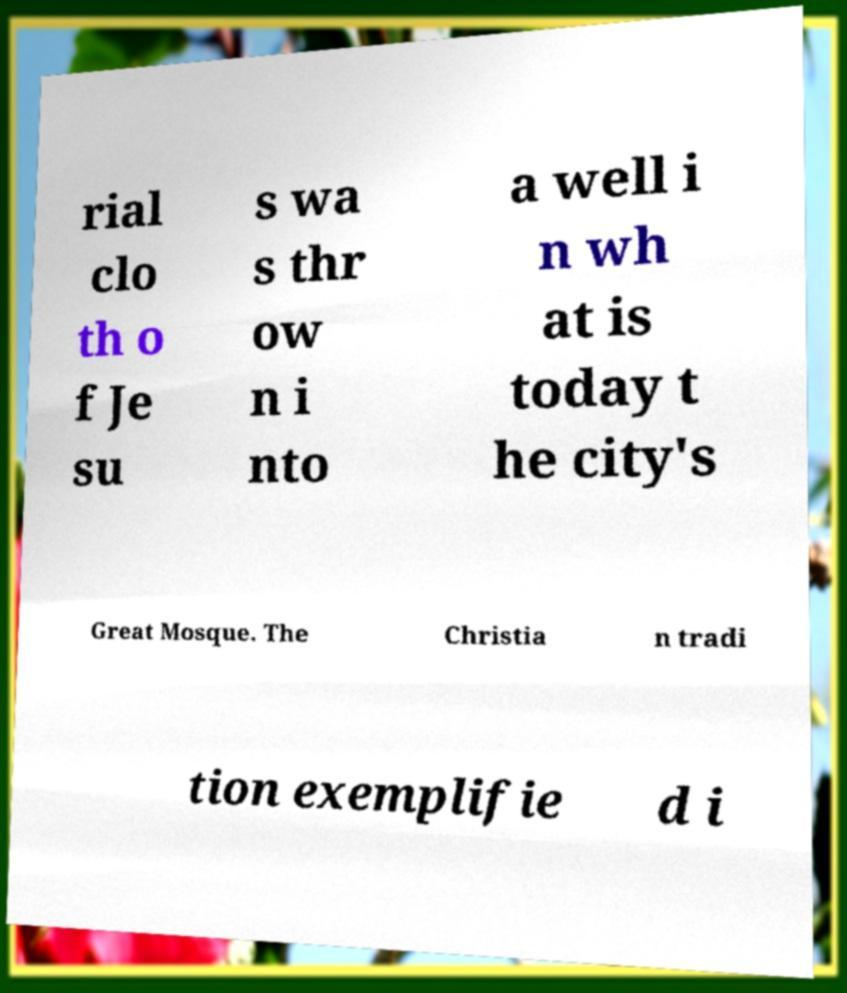I need the written content from this picture converted into text. Can you do that? rial clo th o f Je su s wa s thr ow n i nto a well i n wh at is today t he city's Great Mosque. The Christia n tradi tion exemplifie d i 